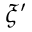<formula> <loc_0><loc_0><loc_500><loc_500>\xi ^ { \prime }</formula> 